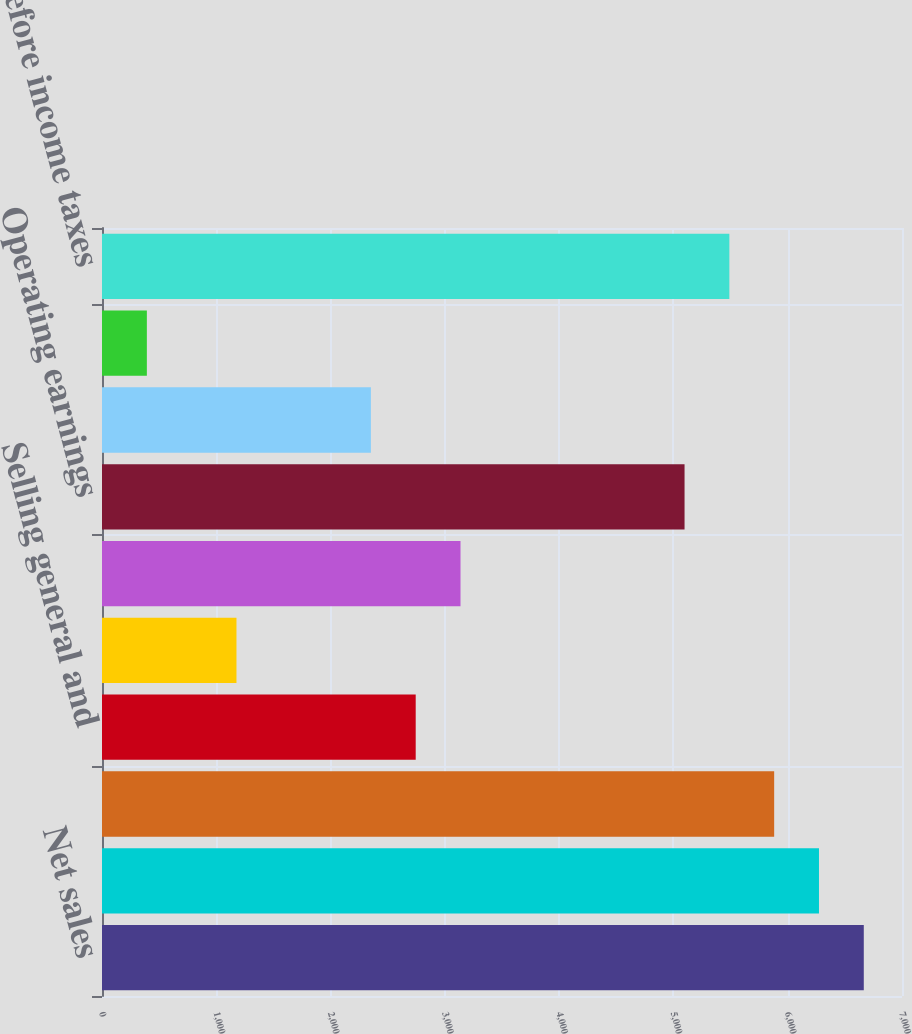Convert chart. <chart><loc_0><loc_0><loc_500><loc_500><bar_chart><fcel>Net sales<fcel>Cost of sales<fcel>Gross margin<fcel>Selling general and<fcel>Other operating-net<fcel>Total other operating costs<fcel>Operating earnings<fcel>Interest expense (income)-net<fcel>Other non-operating-net<fcel>Earnings before income taxes<nl><fcel>6665.59<fcel>6273.52<fcel>5881.45<fcel>2744.89<fcel>1176.61<fcel>3136.96<fcel>5097.31<fcel>2352.82<fcel>392.47<fcel>5489.38<nl></chart> 